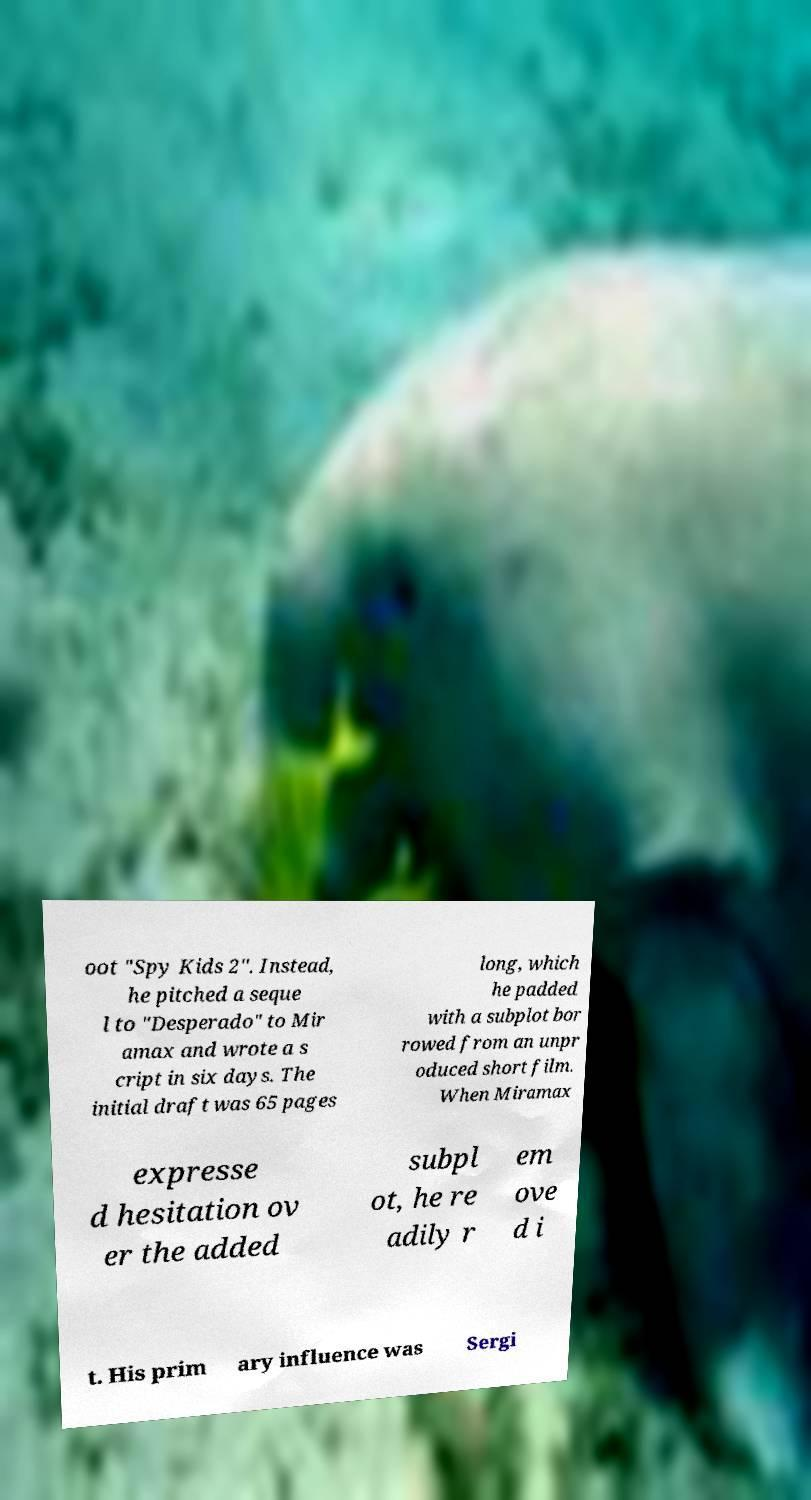I need the written content from this picture converted into text. Can you do that? oot "Spy Kids 2". Instead, he pitched a seque l to "Desperado" to Mir amax and wrote a s cript in six days. The initial draft was 65 pages long, which he padded with a subplot bor rowed from an unpr oduced short film. When Miramax expresse d hesitation ov er the added subpl ot, he re adily r em ove d i t. His prim ary influence was Sergi 